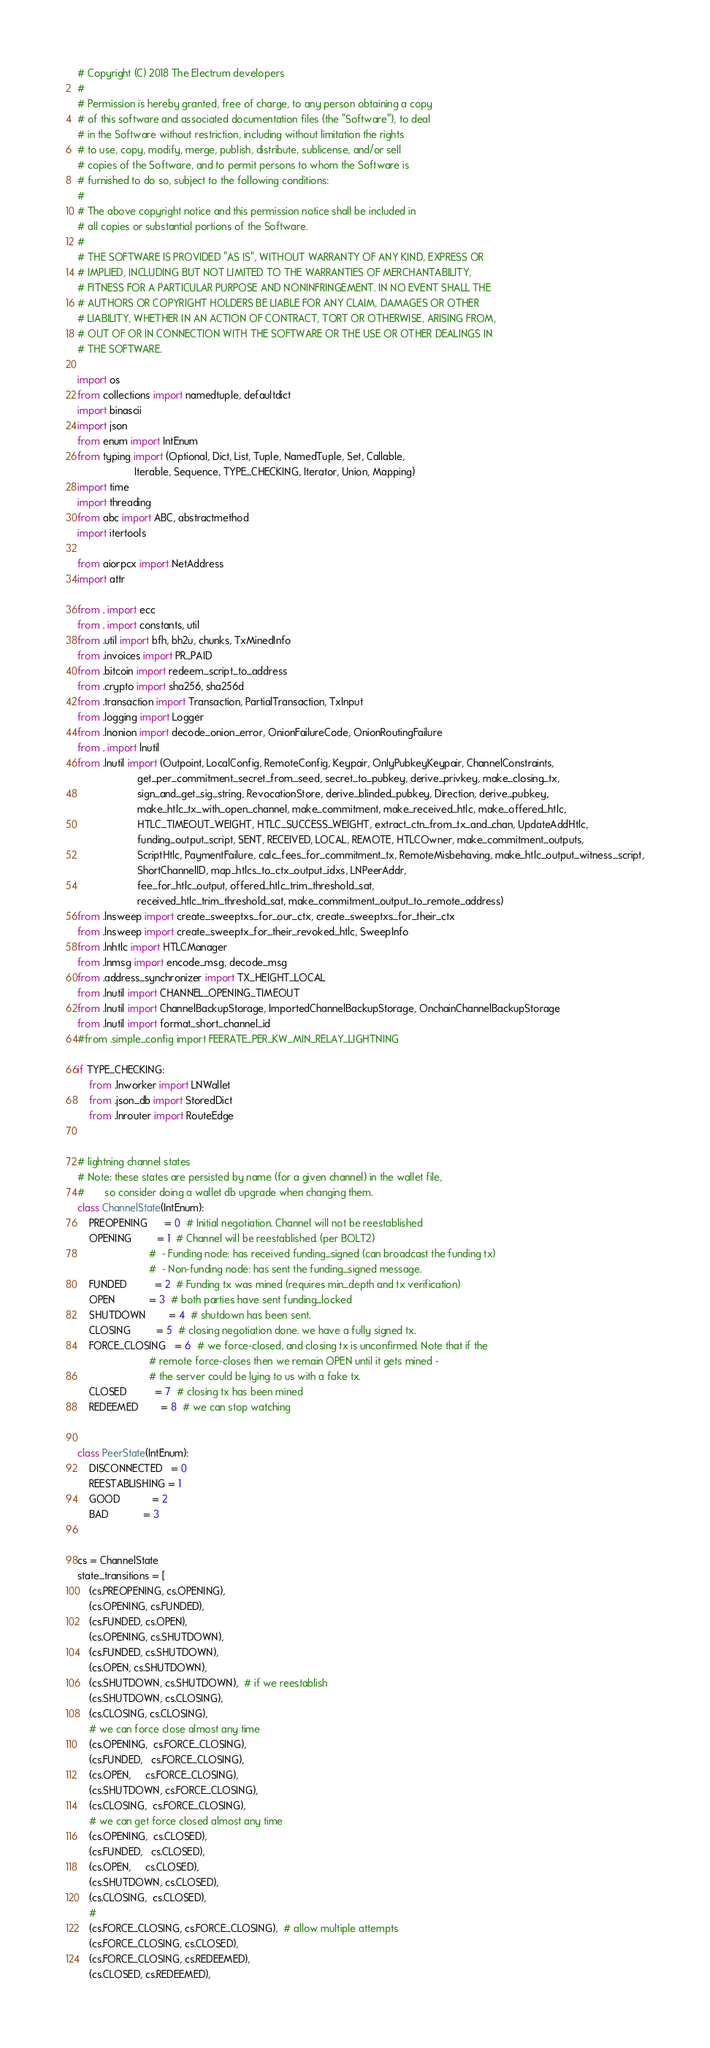Convert code to text. <code><loc_0><loc_0><loc_500><loc_500><_Python_># Copyright (C) 2018 The Electrum developers
#
# Permission is hereby granted, free of charge, to any person obtaining a copy
# of this software and associated documentation files (the "Software"), to deal
# in the Software without restriction, including without limitation the rights
# to use, copy, modify, merge, publish, distribute, sublicense, and/or sell
# copies of the Software, and to permit persons to whom the Software is
# furnished to do so, subject to the following conditions:
#
# The above copyright notice and this permission notice shall be included in
# all copies or substantial portions of the Software.
#
# THE SOFTWARE IS PROVIDED "AS IS", WITHOUT WARRANTY OF ANY KIND, EXPRESS OR
# IMPLIED, INCLUDING BUT NOT LIMITED TO THE WARRANTIES OF MERCHANTABILITY,
# FITNESS FOR A PARTICULAR PURPOSE AND NONINFRINGEMENT. IN NO EVENT SHALL THE
# AUTHORS OR COPYRIGHT HOLDERS BE LIABLE FOR ANY CLAIM, DAMAGES OR OTHER
# LIABILITY, WHETHER IN AN ACTION OF CONTRACT, TORT OR OTHERWISE, ARISING FROM,
# OUT OF OR IN CONNECTION WITH THE SOFTWARE OR THE USE OR OTHER DEALINGS IN
# THE SOFTWARE.

import os
from collections import namedtuple, defaultdict
import binascii
import json
from enum import IntEnum
from typing import (Optional, Dict, List, Tuple, NamedTuple, Set, Callable,
                    Iterable, Sequence, TYPE_CHECKING, Iterator, Union, Mapping)
import time
import threading
from abc import ABC, abstractmethod
import itertools

from aiorpcx import NetAddress
import attr

from . import ecc
from . import constants, util
from .util import bfh, bh2u, chunks, TxMinedInfo
from .invoices import PR_PAID
from .bitcoin import redeem_script_to_address
from .crypto import sha256, sha256d
from .transaction import Transaction, PartialTransaction, TxInput
from .logging import Logger
from .lnonion import decode_onion_error, OnionFailureCode, OnionRoutingFailure
from . import lnutil
from .lnutil import (Outpoint, LocalConfig, RemoteConfig, Keypair, OnlyPubkeyKeypair, ChannelConstraints,
                     get_per_commitment_secret_from_seed, secret_to_pubkey, derive_privkey, make_closing_tx,
                     sign_and_get_sig_string, RevocationStore, derive_blinded_pubkey, Direction, derive_pubkey,
                     make_htlc_tx_with_open_channel, make_commitment, make_received_htlc, make_offered_htlc,
                     HTLC_TIMEOUT_WEIGHT, HTLC_SUCCESS_WEIGHT, extract_ctn_from_tx_and_chan, UpdateAddHtlc,
                     funding_output_script, SENT, RECEIVED, LOCAL, REMOTE, HTLCOwner, make_commitment_outputs,
                     ScriptHtlc, PaymentFailure, calc_fees_for_commitment_tx, RemoteMisbehaving, make_htlc_output_witness_script,
                     ShortChannelID, map_htlcs_to_ctx_output_idxs, LNPeerAddr,
                     fee_for_htlc_output, offered_htlc_trim_threshold_sat,
                     received_htlc_trim_threshold_sat, make_commitment_output_to_remote_address)
from .lnsweep import create_sweeptxs_for_our_ctx, create_sweeptxs_for_their_ctx
from .lnsweep import create_sweeptx_for_their_revoked_htlc, SweepInfo
from .lnhtlc import HTLCManager
from .lnmsg import encode_msg, decode_msg
from .address_synchronizer import TX_HEIGHT_LOCAL
from .lnutil import CHANNEL_OPENING_TIMEOUT
from .lnutil import ChannelBackupStorage, ImportedChannelBackupStorage, OnchainChannelBackupStorage
from .lnutil import format_short_channel_id
#from .simple_config import FEERATE_PER_KW_MIN_RELAY_LIGHTNING

if TYPE_CHECKING:
    from .lnworker import LNWallet
    from .json_db import StoredDict
    from .lnrouter import RouteEdge


# lightning channel states
# Note: these states are persisted by name (for a given channel) in the wallet file,
#       so consider doing a wallet db upgrade when changing them.
class ChannelState(IntEnum):
    PREOPENING      = 0  # Initial negotiation. Channel will not be reestablished
    OPENING         = 1  # Channel will be reestablished. (per BOLT2)
                         #  - Funding node: has received funding_signed (can broadcast the funding tx)
                         #  - Non-funding node: has sent the funding_signed message.
    FUNDED          = 2  # Funding tx was mined (requires min_depth and tx verification)
    OPEN            = 3  # both parties have sent funding_locked
    SHUTDOWN        = 4  # shutdown has been sent.
    CLOSING         = 5  # closing negotiation done. we have a fully signed tx.
    FORCE_CLOSING   = 6  # we force-closed, and closing tx is unconfirmed. Note that if the
                         # remote force-closes then we remain OPEN until it gets mined -
                         # the server could be lying to us with a fake tx.
    CLOSED          = 7  # closing tx has been mined
    REDEEMED        = 8  # we can stop watching


class PeerState(IntEnum):
    DISCONNECTED   = 0
    REESTABLISHING = 1
    GOOD           = 2
    BAD            = 3


cs = ChannelState
state_transitions = [
    (cs.PREOPENING, cs.OPENING),
    (cs.OPENING, cs.FUNDED),
    (cs.FUNDED, cs.OPEN),
    (cs.OPENING, cs.SHUTDOWN),
    (cs.FUNDED, cs.SHUTDOWN),
    (cs.OPEN, cs.SHUTDOWN),
    (cs.SHUTDOWN, cs.SHUTDOWN),  # if we reestablish
    (cs.SHUTDOWN, cs.CLOSING),
    (cs.CLOSING, cs.CLOSING),
    # we can force close almost any time
    (cs.OPENING,  cs.FORCE_CLOSING),
    (cs.FUNDED,   cs.FORCE_CLOSING),
    (cs.OPEN,     cs.FORCE_CLOSING),
    (cs.SHUTDOWN, cs.FORCE_CLOSING),
    (cs.CLOSING,  cs.FORCE_CLOSING),
    # we can get force closed almost any time
    (cs.OPENING,  cs.CLOSED),
    (cs.FUNDED,   cs.CLOSED),
    (cs.OPEN,     cs.CLOSED),
    (cs.SHUTDOWN, cs.CLOSED),
    (cs.CLOSING,  cs.CLOSED),
    #
    (cs.FORCE_CLOSING, cs.FORCE_CLOSING),  # allow multiple attempts
    (cs.FORCE_CLOSING, cs.CLOSED),
    (cs.FORCE_CLOSING, cs.REDEEMED),
    (cs.CLOSED, cs.REDEEMED),</code> 